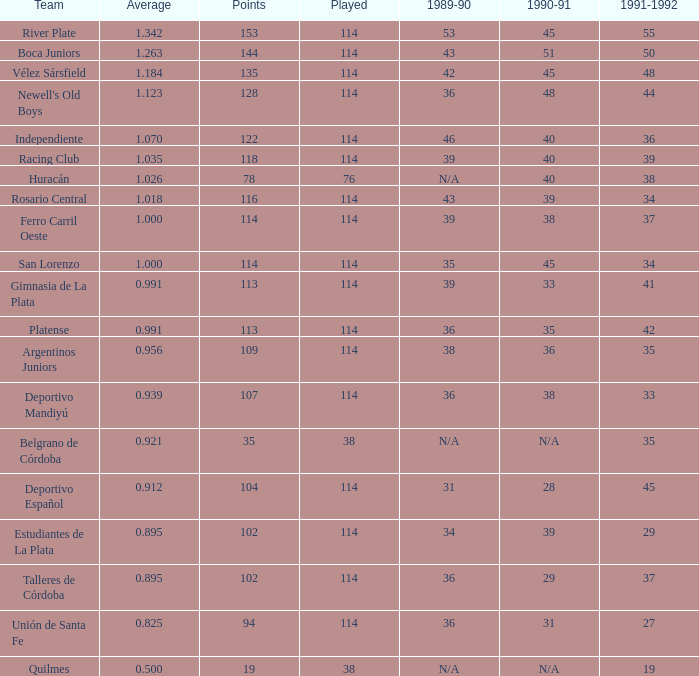Given a 1989-90 value of 36 and an average of 0.8250000000000001, what is the corresponding amount for 1991-1992? 0.0. 